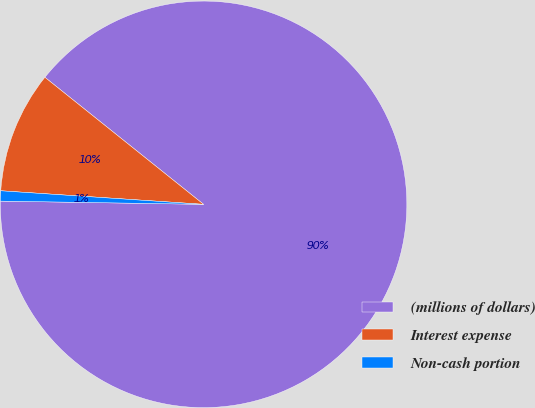Convert chart. <chart><loc_0><loc_0><loc_500><loc_500><pie_chart><fcel>(millions of dollars)<fcel>Interest expense<fcel>Non-cash portion<nl><fcel>89.5%<fcel>9.68%<fcel>0.81%<nl></chart> 